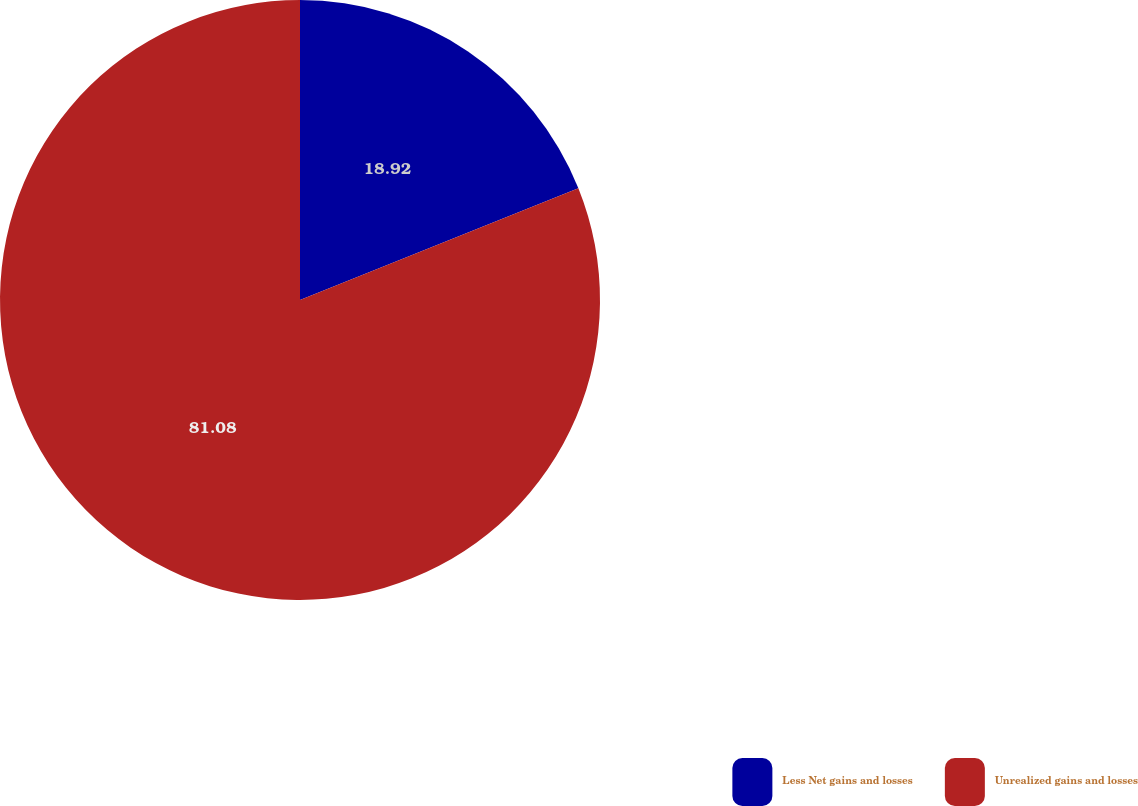Convert chart to OTSL. <chart><loc_0><loc_0><loc_500><loc_500><pie_chart><fcel>Less Net gains and losses<fcel>Unrealized gains and losses<nl><fcel>18.92%<fcel>81.08%<nl></chart> 